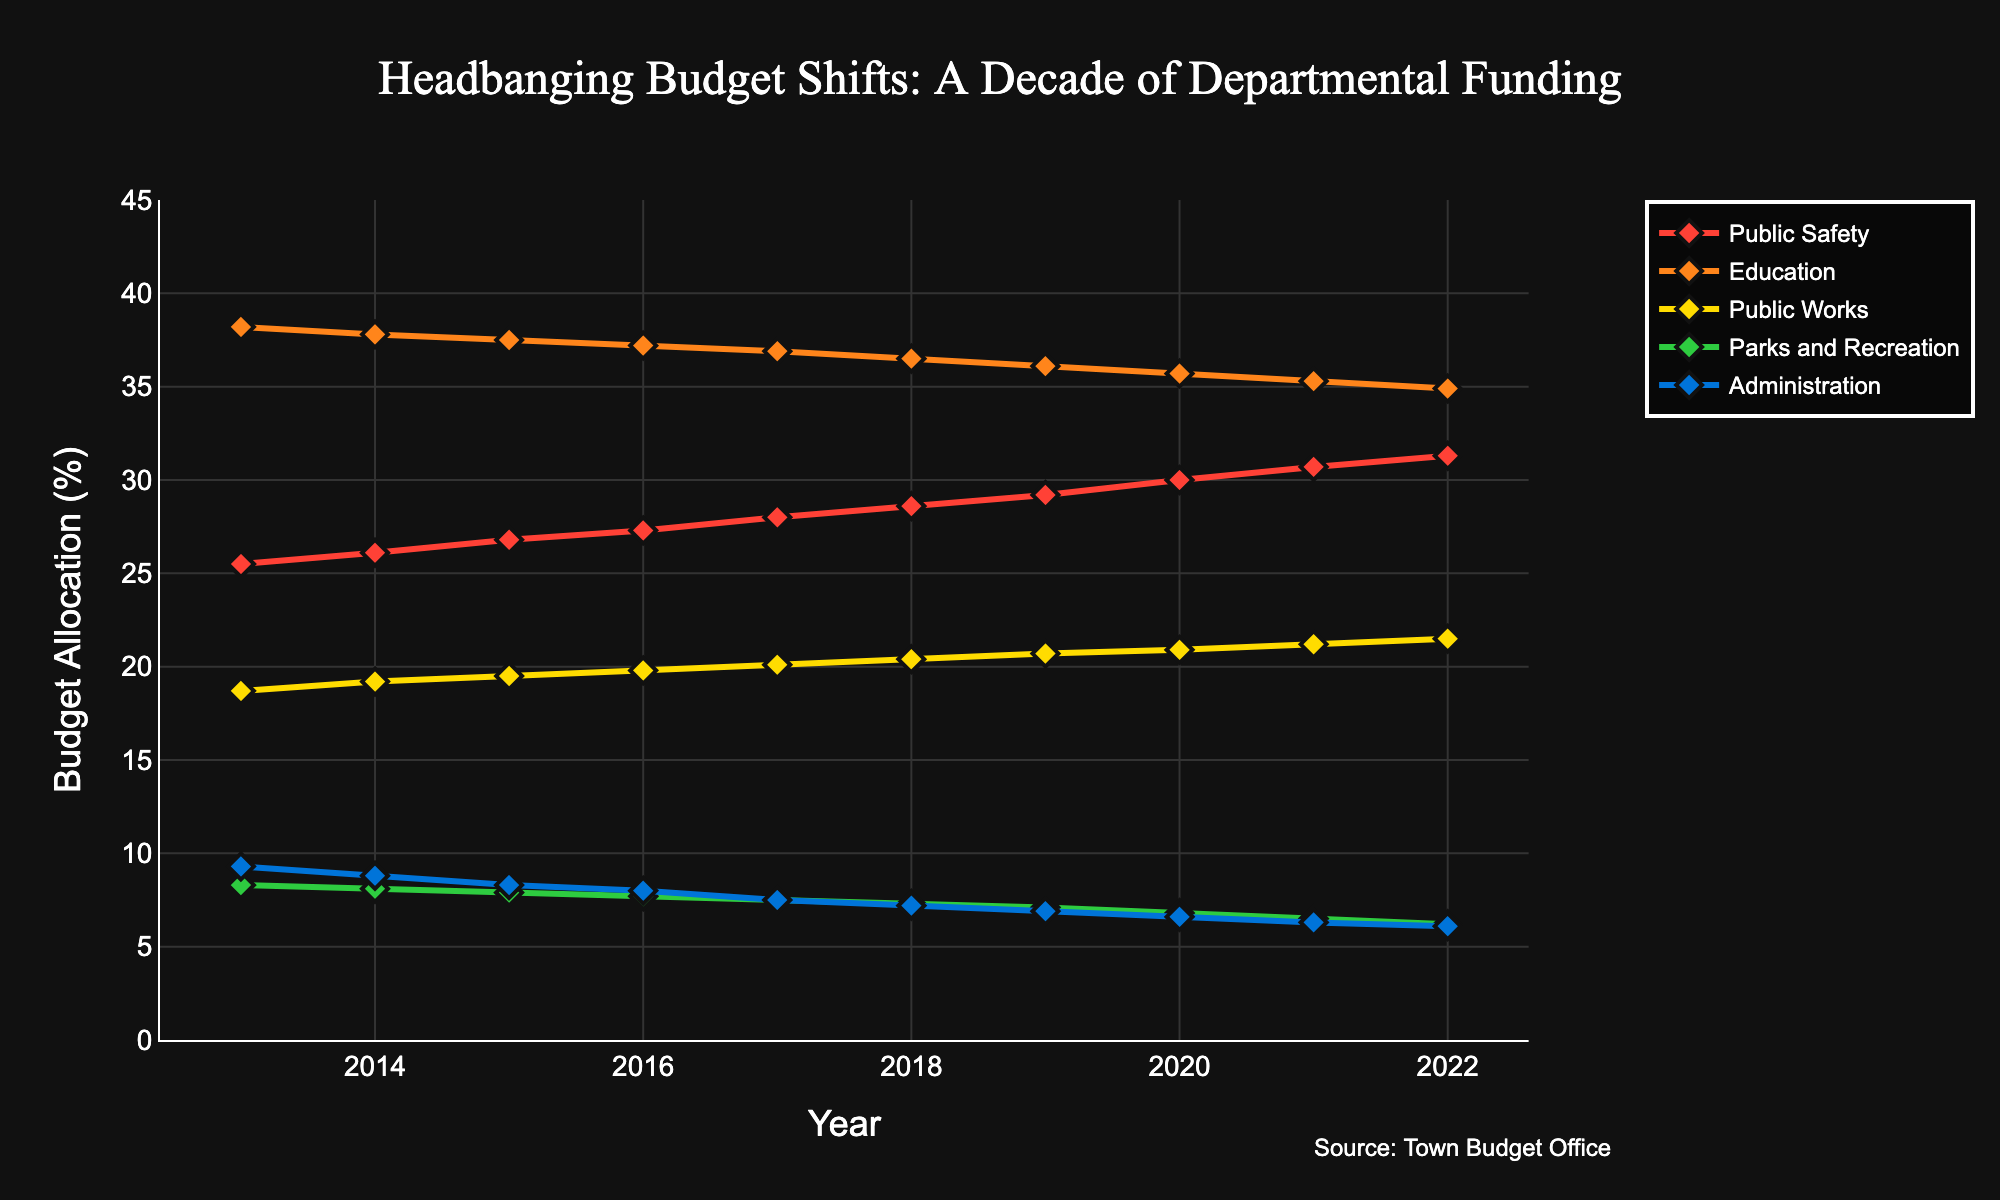What department had the highest budget allocation in 2022? Looking at the graph for the year 2022, the department with the highest peak in the respective line is Education.
Answer: Education Which two departments had the largest difference in budget allocation in 2020? In 2020, Education had a budget allocation of 35.7% and Public Safety had 30.0%. The difference between them is 35.7 - 30.0 = 5.7 percentage points.
Answer: Education and Public Safety How did the budget for Parks and Recreation change from 2013 to 2022? The budget for Parks and Recreation in 2013 was 8.3% and in 2022 it was 6.2%. The change is 6.2 - 8.3 = -2.1 percentage points, indicating a decrease.
Answer: Decreased by 2.1 percentage points Which department's budget saw the most consistent increase over the decade? By inspecting the lines on the graph, Public Safety shows a steady upward trend from 25.5% in 2013 to 31.3% in 2022 without any declines.
Answer: Public Safety What is the average budget allocation for Public Works over the decade? Sum the allocations from 2013 to 2022 for Public Works: 18.7 + 19.2 + 19.5 + 19.8 + 20.1 + 20.4 + 20.7 + 20.9 + 21.2 + 21.5 = 202.0. The average is 202.0 / 10 = 20.2%.
Answer: 20.2% Did any department's budget allocation fall below 7% at any point, and if so, which one(s)? Looking at the graph, Parks and Recreation's budget allocation fell below 7% starting from 2019 to 2022 (7.1%, 6.8%, 6.5%, 6.2%).
Answer: Parks and Recreation Between 2018 and 2019, which department experienced the biggest decrease in budget allocation? Education saw a decline from 36.5% in 2018 to 36.1% in 2019, which is a drop of 0.4 percentage points, the largest decrease among all departments for that period.
Answer: Education In which year did the Administration department have the smallest budget allocation, and what was it? Observing the graph, Administration had its smallest budget allocation in 2022, which was 6.1%.
Answer: 2022, 6.1% Which department had the lowest variability in budget allocation over the period? Comparing the lines for each department, Education has the least steep slope and fewer fluctuations, indicating it has the lowest variability in budget allocation.
Answer: Education 